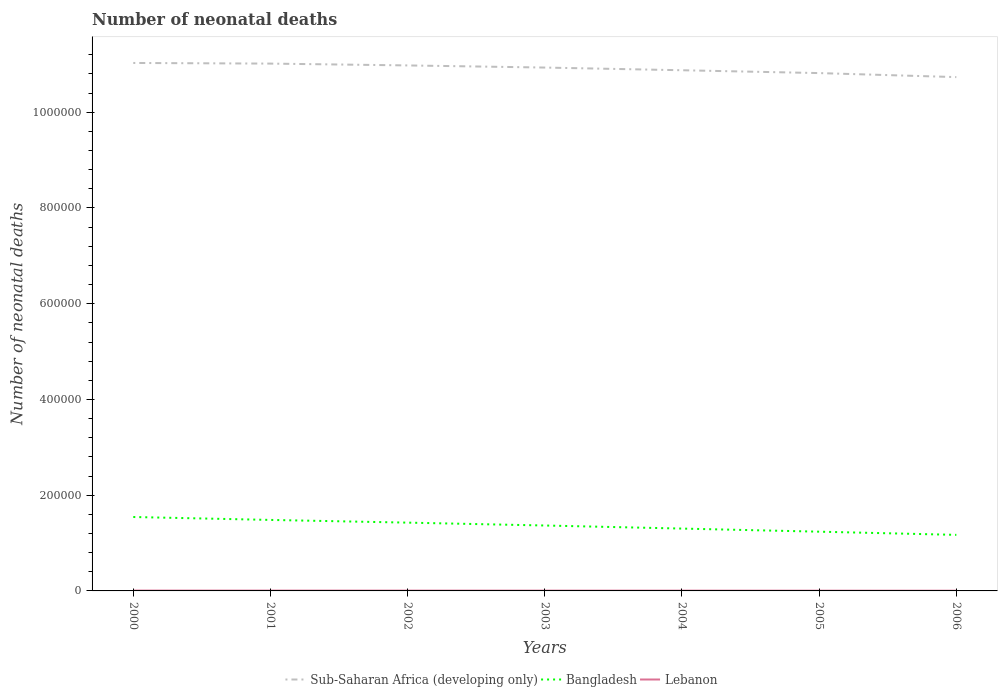Does the line corresponding to Bangladesh intersect with the line corresponding to Lebanon?
Your answer should be compact. No. Is the number of lines equal to the number of legend labels?
Your answer should be very brief. Yes. Across all years, what is the maximum number of neonatal deaths in in Bangladesh?
Keep it short and to the point. 1.17e+05. What is the total number of neonatal deaths in in Lebanon in the graph?
Make the answer very short. 65. What is the difference between the highest and the second highest number of neonatal deaths in in Bangladesh?
Keep it short and to the point. 3.73e+04. How many years are there in the graph?
Your response must be concise. 7. What is the difference between two consecutive major ticks on the Y-axis?
Keep it short and to the point. 2.00e+05. Are the values on the major ticks of Y-axis written in scientific E-notation?
Provide a succinct answer. No. Does the graph contain any zero values?
Your response must be concise. No. Does the graph contain grids?
Provide a succinct answer. No. What is the title of the graph?
Provide a short and direct response. Number of neonatal deaths. Does "Algeria" appear as one of the legend labels in the graph?
Provide a succinct answer. No. What is the label or title of the X-axis?
Give a very brief answer. Years. What is the label or title of the Y-axis?
Your answer should be compact. Number of neonatal deaths. What is the Number of neonatal deaths of Sub-Saharan Africa (developing only) in 2000?
Keep it short and to the point. 1.10e+06. What is the Number of neonatal deaths of Bangladesh in 2000?
Give a very brief answer. 1.54e+05. What is the Number of neonatal deaths in Lebanon in 2000?
Your answer should be very brief. 720. What is the Number of neonatal deaths in Sub-Saharan Africa (developing only) in 2001?
Keep it short and to the point. 1.10e+06. What is the Number of neonatal deaths in Bangladesh in 2001?
Your answer should be compact. 1.48e+05. What is the Number of neonatal deaths in Lebanon in 2001?
Provide a short and direct response. 678. What is the Number of neonatal deaths of Sub-Saharan Africa (developing only) in 2002?
Provide a succinct answer. 1.10e+06. What is the Number of neonatal deaths in Bangladesh in 2002?
Your response must be concise. 1.43e+05. What is the Number of neonatal deaths in Lebanon in 2002?
Give a very brief answer. 641. What is the Number of neonatal deaths of Sub-Saharan Africa (developing only) in 2003?
Ensure brevity in your answer.  1.09e+06. What is the Number of neonatal deaths of Bangladesh in 2003?
Your response must be concise. 1.37e+05. What is the Number of neonatal deaths of Lebanon in 2003?
Your answer should be compact. 613. What is the Number of neonatal deaths in Sub-Saharan Africa (developing only) in 2004?
Provide a succinct answer. 1.09e+06. What is the Number of neonatal deaths in Bangladesh in 2004?
Provide a succinct answer. 1.30e+05. What is the Number of neonatal deaths in Lebanon in 2004?
Keep it short and to the point. 572. What is the Number of neonatal deaths in Sub-Saharan Africa (developing only) in 2005?
Provide a short and direct response. 1.08e+06. What is the Number of neonatal deaths in Bangladesh in 2005?
Keep it short and to the point. 1.24e+05. What is the Number of neonatal deaths of Lebanon in 2005?
Your answer should be compact. 513. What is the Number of neonatal deaths of Sub-Saharan Africa (developing only) in 2006?
Your answer should be very brief. 1.07e+06. What is the Number of neonatal deaths of Bangladesh in 2006?
Your answer should be very brief. 1.17e+05. What is the Number of neonatal deaths of Lebanon in 2006?
Your answer should be very brief. 443. Across all years, what is the maximum Number of neonatal deaths of Sub-Saharan Africa (developing only)?
Your answer should be very brief. 1.10e+06. Across all years, what is the maximum Number of neonatal deaths of Bangladesh?
Ensure brevity in your answer.  1.54e+05. Across all years, what is the maximum Number of neonatal deaths in Lebanon?
Give a very brief answer. 720. Across all years, what is the minimum Number of neonatal deaths in Sub-Saharan Africa (developing only)?
Ensure brevity in your answer.  1.07e+06. Across all years, what is the minimum Number of neonatal deaths in Bangladesh?
Your response must be concise. 1.17e+05. Across all years, what is the minimum Number of neonatal deaths of Lebanon?
Your answer should be compact. 443. What is the total Number of neonatal deaths in Sub-Saharan Africa (developing only) in the graph?
Offer a terse response. 7.64e+06. What is the total Number of neonatal deaths of Bangladesh in the graph?
Give a very brief answer. 9.53e+05. What is the total Number of neonatal deaths of Lebanon in the graph?
Your response must be concise. 4180. What is the difference between the Number of neonatal deaths of Sub-Saharan Africa (developing only) in 2000 and that in 2001?
Make the answer very short. 1326. What is the difference between the Number of neonatal deaths in Bangladesh in 2000 and that in 2001?
Make the answer very short. 6113. What is the difference between the Number of neonatal deaths of Sub-Saharan Africa (developing only) in 2000 and that in 2002?
Offer a terse response. 5137. What is the difference between the Number of neonatal deaths of Bangladesh in 2000 and that in 2002?
Give a very brief answer. 1.18e+04. What is the difference between the Number of neonatal deaths of Lebanon in 2000 and that in 2002?
Your answer should be very brief. 79. What is the difference between the Number of neonatal deaths in Sub-Saharan Africa (developing only) in 2000 and that in 2003?
Provide a short and direct response. 9601. What is the difference between the Number of neonatal deaths in Bangladesh in 2000 and that in 2003?
Provide a short and direct response. 1.78e+04. What is the difference between the Number of neonatal deaths in Lebanon in 2000 and that in 2003?
Offer a very short reply. 107. What is the difference between the Number of neonatal deaths in Sub-Saharan Africa (developing only) in 2000 and that in 2004?
Make the answer very short. 1.52e+04. What is the difference between the Number of neonatal deaths in Bangladesh in 2000 and that in 2004?
Offer a very short reply. 2.42e+04. What is the difference between the Number of neonatal deaths in Lebanon in 2000 and that in 2004?
Provide a short and direct response. 148. What is the difference between the Number of neonatal deaths of Sub-Saharan Africa (developing only) in 2000 and that in 2005?
Your answer should be compact. 2.11e+04. What is the difference between the Number of neonatal deaths in Bangladesh in 2000 and that in 2005?
Provide a short and direct response. 3.07e+04. What is the difference between the Number of neonatal deaths in Lebanon in 2000 and that in 2005?
Offer a terse response. 207. What is the difference between the Number of neonatal deaths of Sub-Saharan Africa (developing only) in 2000 and that in 2006?
Your answer should be very brief. 2.95e+04. What is the difference between the Number of neonatal deaths in Bangladesh in 2000 and that in 2006?
Your response must be concise. 3.73e+04. What is the difference between the Number of neonatal deaths of Lebanon in 2000 and that in 2006?
Offer a very short reply. 277. What is the difference between the Number of neonatal deaths of Sub-Saharan Africa (developing only) in 2001 and that in 2002?
Your answer should be very brief. 3811. What is the difference between the Number of neonatal deaths in Bangladesh in 2001 and that in 2002?
Give a very brief answer. 5643. What is the difference between the Number of neonatal deaths of Sub-Saharan Africa (developing only) in 2001 and that in 2003?
Provide a short and direct response. 8275. What is the difference between the Number of neonatal deaths in Bangladesh in 2001 and that in 2003?
Keep it short and to the point. 1.16e+04. What is the difference between the Number of neonatal deaths of Lebanon in 2001 and that in 2003?
Offer a very short reply. 65. What is the difference between the Number of neonatal deaths of Sub-Saharan Africa (developing only) in 2001 and that in 2004?
Make the answer very short. 1.39e+04. What is the difference between the Number of neonatal deaths of Bangladesh in 2001 and that in 2004?
Keep it short and to the point. 1.81e+04. What is the difference between the Number of neonatal deaths of Lebanon in 2001 and that in 2004?
Your answer should be compact. 106. What is the difference between the Number of neonatal deaths in Sub-Saharan Africa (developing only) in 2001 and that in 2005?
Your response must be concise. 1.98e+04. What is the difference between the Number of neonatal deaths of Bangladesh in 2001 and that in 2005?
Offer a terse response. 2.46e+04. What is the difference between the Number of neonatal deaths of Lebanon in 2001 and that in 2005?
Provide a succinct answer. 165. What is the difference between the Number of neonatal deaths of Sub-Saharan Africa (developing only) in 2001 and that in 2006?
Provide a succinct answer. 2.82e+04. What is the difference between the Number of neonatal deaths of Bangladesh in 2001 and that in 2006?
Give a very brief answer. 3.12e+04. What is the difference between the Number of neonatal deaths of Lebanon in 2001 and that in 2006?
Make the answer very short. 235. What is the difference between the Number of neonatal deaths in Sub-Saharan Africa (developing only) in 2002 and that in 2003?
Your answer should be very brief. 4464. What is the difference between the Number of neonatal deaths of Bangladesh in 2002 and that in 2003?
Provide a succinct answer. 6004. What is the difference between the Number of neonatal deaths in Sub-Saharan Africa (developing only) in 2002 and that in 2004?
Ensure brevity in your answer.  1.01e+04. What is the difference between the Number of neonatal deaths in Bangladesh in 2002 and that in 2004?
Provide a succinct answer. 1.24e+04. What is the difference between the Number of neonatal deaths of Lebanon in 2002 and that in 2004?
Ensure brevity in your answer.  69. What is the difference between the Number of neonatal deaths of Sub-Saharan Africa (developing only) in 2002 and that in 2005?
Offer a very short reply. 1.60e+04. What is the difference between the Number of neonatal deaths in Bangladesh in 2002 and that in 2005?
Offer a terse response. 1.89e+04. What is the difference between the Number of neonatal deaths in Lebanon in 2002 and that in 2005?
Your response must be concise. 128. What is the difference between the Number of neonatal deaths in Sub-Saharan Africa (developing only) in 2002 and that in 2006?
Make the answer very short. 2.44e+04. What is the difference between the Number of neonatal deaths of Bangladesh in 2002 and that in 2006?
Give a very brief answer. 2.56e+04. What is the difference between the Number of neonatal deaths of Lebanon in 2002 and that in 2006?
Your answer should be very brief. 198. What is the difference between the Number of neonatal deaths in Sub-Saharan Africa (developing only) in 2003 and that in 2004?
Keep it short and to the point. 5609. What is the difference between the Number of neonatal deaths of Bangladesh in 2003 and that in 2004?
Your response must be concise. 6423. What is the difference between the Number of neonatal deaths in Sub-Saharan Africa (developing only) in 2003 and that in 2005?
Give a very brief answer. 1.15e+04. What is the difference between the Number of neonatal deaths of Bangladesh in 2003 and that in 2005?
Ensure brevity in your answer.  1.29e+04. What is the difference between the Number of neonatal deaths in Sub-Saharan Africa (developing only) in 2003 and that in 2006?
Provide a short and direct response. 1.99e+04. What is the difference between the Number of neonatal deaths in Bangladesh in 2003 and that in 2006?
Ensure brevity in your answer.  1.96e+04. What is the difference between the Number of neonatal deaths in Lebanon in 2003 and that in 2006?
Offer a terse response. 170. What is the difference between the Number of neonatal deaths of Sub-Saharan Africa (developing only) in 2004 and that in 2005?
Your answer should be compact. 5939. What is the difference between the Number of neonatal deaths of Bangladesh in 2004 and that in 2005?
Give a very brief answer. 6481. What is the difference between the Number of neonatal deaths of Sub-Saharan Africa (developing only) in 2004 and that in 2006?
Your answer should be very brief. 1.43e+04. What is the difference between the Number of neonatal deaths of Bangladesh in 2004 and that in 2006?
Give a very brief answer. 1.31e+04. What is the difference between the Number of neonatal deaths in Lebanon in 2004 and that in 2006?
Give a very brief answer. 129. What is the difference between the Number of neonatal deaths in Sub-Saharan Africa (developing only) in 2005 and that in 2006?
Your answer should be very brief. 8397. What is the difference between the Number of neonatal deaths of Bangladesh in 2005 and that in 2006?
Provide a short and direct response. 6658. What is the difference between the Number of neonatal deaths of Lebanon in 2005 and that in 2006?
Make the answer very short. 70. What is the difference between the Number of neonatal deaths in Sub-Saharan Africa (developing only) in 2000 and the Number of neonatal deaths in Bangladesh in 2001?
Keep it short and to the point. 9.55e+05. What is the difference between the Number of neonatal deaths in Sub-Saharan Africa (developing only) in 2000 and the Number of neonatal deaths in Lebanon in 2001?
Provide a short and direct response. 1.10e+06. What is the difference between the Number of neonatal deaths of Bangladesh in 2000 and the Number of neonatal deaths of Lebanon in 2001?
Provide a short and direct response. 1.54e+05. What is the difference between the Number of neonatal deaths in Sub-Saharan Africa (developing only) in 2000 and the Number of neonatal deaths in Bangladesh in 2002?
Your response must be concise. 9.60e+05. What is the difference between the Number of neonatal deaths of Sub-Saharan Africa (developing only) in 2000 and the Number of neonatal deaths of Lebanon in 2002?
Make the answer very short. 1.10e+06. What is the difference between the Number of neonatal deaths of Bangladesh in 2000 and the Number of neonatal deaths of Lebanon in 2002?
Your answer should be compact. 1.54e+05. What is the difference between the Number of neonatal deaths in Sub-Saharan Africa (developing only) in 2000 and the Number of neonatal deaths in Bangladesh in 2003?
Offer a terse response. 9.66e+05. What is the difference between the Number of neonatal deaths of Sub-Saharan Africa (developing only) in 2000 and the Number of neonatal deaths of Lebanon in 2003?
Provide a short and direct response. 1.10e+06. What is the difference between the Number of neonatal deaths of Bangladesh in 2000 and the Number of neonatal deaths of Lebanon in 2003?
Provide a short and direct response. 1.54e+05. What is the difference between the Number of neonatal deaths in Sub-Saharan Africa (developing only) in 2000 and the Number of neonatal deaths in Bangladesh in 2004?
Provide a short and direct response. 9.73e+05. What is the difference between the Number of neonatal deaths in Sub-Saharan Africa (developing only) in 2000 and the Number of neonatal deaths in Lebanon in 2004?
Provide a short and direct response. 1.10e+06. What is the difference between the Number of neonatal deaths in Bangladesh in 2000 and the Number of neonatal deaths in Lebanon in 2004?
Give a very brief answer. 1.54e+05. What is the difference between the Number of neonatal deaths of Sub-Saharan Africa (developing only) in 2000 and the Number of neonatal deaths of Bangladesh in 2005?
Your answer should be compact. 9.79e+05. What is the difference between the Number of neonatal deaths of Sub-Saharan Africa (developing only) in 2000 and the Number of neonatal deaths of Lebanon in 2005?
Your response must be concise. 1.10e+06. What is the difference between the Number of neonatal deaths in Bangladesh in 2000 and the Number of neonatal deaths in Lebanon in 2005?
Ensure brevity in your answer.  1.54e+05. What is the difference between the Number of neonatal deaths in Sub-Saharan Africa (developing only) in 2000 and the Number of neonatal deaths in Bangladesh in 2006?
Ensure brevity in your answer.  9.86e+05. What is the difference between the Number of neonatal deaths in Sub-Saharan Africa (developing only) in 2000 and the Number of neonatal deaths in Lebanon in 2006?
Give a very brief answer. 1.10e+06. What is the difference between the Number of neonatal deaths of Bangladesh in 2000 and the Number of neonatal deaths of Lebanon in 2006?
Keep it short and to the point. 1.54e+05. What is the difference between the Number of neonatal deaths of Sub-Saharan Africa (developing only) in 2001 and the Number of neonatal deaths of Bangladesh in 2002?
Ensure brevity in your answer.  9.59e+05. What is the difference between the Number of neonatal deaths in Sub-Saharan Africa (developing only) in 2001 and the Number of neonatal deaths in Lebanon in 2002?
Offer a terse response. 1.10e+06. What is the difference between the Number of neonatal deaths in Bangladesh in 2001 and the Number of neonatal deaths in Lebanon in 2002?
Your answer should be very brief. 1.48e+05. What is the difference between the Number of neonatal deaths of Sub-Saharan Africa (developing only) in 2001 and the Number of neonatal deaths of Bangladesh in 2003?
Your response must be concise. 9.65e+05. What is the difference between the Number of neonatal deaths in Sub-Saharan Africa (developing only) in 2001 and the Number of neonatal deaths in Lebanon in 2003?
Your response must be concise. 1.10e+06. What is the difference between the Number of neonatal deaths in Bangladesh in 2001 and the Number of neonatal deaths in Lebanon in 2003?
Provide a short and direct response. 1.48e+05. What is the difference between the Number of neonatal deaths of Sub-Saharan Africa (developing only) in 2001 and the Number of neonatal deaths of Bangladesh in 2004?
Your answer should be compact. 9.71e+05. What is the difference between the Number of neonatal deaths of Sub-Saharan Africa (developing only) in 2001 and the Number of neonatal deaths of Lebanon in 2004?
Provide a short and direct response. 1.10e+06. What is the difference between the Number of neonatal deaths in Bangladesh in 2001 and the Number of neonatal deaths in Lebanon in 2004?
Keep it short and to the point. 1.48e+05. What is the difference between the Number of neonatal deaths of Sub-Saharan Africa (developing only) in 2001 and the Number of neonatal deaths of Bangladesh in 2005?
Offer a very short reply. 9.78e+05. What is the difference between the Number of neonatal deaths in Sub-Saharan Africa (developing only) in 2001 and the Number of neonatal deaths in Lebanon in 2005?
Your response must be concise. 1.10e+06. What is the difference between the Number of neonatal deaths in Bangladesh in 2001 and the Number of neonatal deaths in Lebanon in 2005?
Offer a very short reply. 1.48e+05. What is the difference between the Number of neonatal deaths of Sub-Saharan Africa (developing only) in 2001 and the Number of neonatal deaths of Bangladesh in 2006?
Ensure brevity in your answer.  9.85e+05. What is the difference between the Number of neonatal deaths of Sub-Saharan Africa (developing only) in 2001 and the Number of neonatal deaths of Lebanon in 2006?
Give a very brief answer. 1.10e+06. What is the difference between the Number of neonatal deaths in Bangladesh in 2001 and the Number of neonatal deaths in Lebanon in 2006?
Your response must be concise. 1.48e+05. What is the difference between the Number of neonatal deaths of Sub-Saharan Africa (developing only) in 2002 and the Number of neonatal deaths of Bangladesh in 2003?
Offer a terse response. 9.61e+05. What is the difference between the Number of neonatal deaths in Sub-Saharan Africa (developing only) in 2002 and the Number of neonatal deaths in Lebanon in 2003?
Make the answer very short. 1.10e+06. What is the difference between the Number of neonatal deaths in Bangladesh in 2002 and the Number of neonatal deaths in Lebanon in 2003?
Your answer should be very brief. 1.42e+05. What is the difference between the Number of neonatal deaths of Sub-Saharan Africa (developing only) in 2002 and the Number of neonatal deaths of Bangladesh in 2004?
Your answer should be very brief. 9.68e+05. What is the difference between the Number of neonatal deaths in Sub-Saharan Africa (developing only) in 2002 and the Number of neonatal deaths in Lebanon in 2004?
Offer a very short reply. 1.10e+06. What is the difference between the Number of neonatal deaths in Bangladesh in 2002 and the Number of neonatal deaths in Lebanon in 2004?
Your answer should be very brief. 1.42e+05. What is the difference between the Number of neonatal deaths in Sub-Saharan Africa (developing only) in 2002 and the Number of neonatal deaths in Bangladesh in 2005?
Your answer should be compact. 9.74e+05. What is the difference between the Number of neonatal deaths of Sub-Saharan Africa (developing only) in 2002 and the Number of neonatal deaths of Lebanon in 2005?
Give a very brief answer. 1.10e+06. What is the difference between the Number of neonatal deaths of Bangladesh in 2002 and the Number of neonatal deaths of Lebanon in 2005?
Offer a very short reply. 1.42e+05. What is the difference between the Number of neonatal deaths of Sub-Saharan Africa (developing only) in 2002 and the Number of neonatal deaths of Bangladesh in 2006?
Keep it short and to the point. 9.81e+05. What is the difference between the Number of neonatal deaths in Sub-Saharan Africa (developing only) in 2002 and the Number of neonatal deaths in Lebanon in 2006?
Your answer should be very brief. 1.10e+06. What is the difference between the Number of neonatal deaths in Bangladesh in 2002 and the Number of neonatal deaths in Lebanon in 2006?
Your response must be concise. 1.42e+05. What is the difference between the Number of neonatal deaths in Sub-Saharan Africa (developing only) in 2003 and the Number of neonatal deaths in Bangladesh in 2004?
Ensure brevity in your answer.  9.63e+05. What is the difference between the Number of neonatal deaths in Sub-Saharan Africa (developing only) in 2003 and the Number of neonatal deaths in Lebanon in 2004?
Provide a succinct answer. 1.09e+06. What is the difference between the Number of neonatal deaths in Bangladesh in 2003 and the Number of neonatal deaths in Lebanon in 2004?
Give a very brief answer. 1.36e+05. What is the difference between the Number of neonatal deaths in Sub-Saharan Africa (developing only) in 2003 and the Number of neonatal deaths in Bangladesh in 2005?
Give a very brief answer. 9.70e+05. What is the difference between the Number of neonatal deaths in Sub-Saharan Africa (developing only) in 2003 and the Number of neonatal deaths in Lebanon in 2005?
Provide a succinct answer. 1.09e+06. What is the difference between the Number of neonatal deaths of Bangladesh in 2003 and the Number of neonatal deaths of Lebanon in 2005?
Keep it short and to the point. 1.36e+05. What is the difference between the Number of neonatal deaths of Sub-Saharan Africa (developing only) in 2003 and the Number of neonatal deaths of Bangladesh in 2006?
Provide a succinct answer. 9.76e+05. What is the difference between the Number of neonatal deaths in Sub-Saharan Africa (developing only) in 2003 and the Number of neonatal deaths in Lebanon in 2006?
Keep it short and to the point. 1.09e+06. What is the difference between the Number of neonatal deaths in Bangladesh in 2003 and the Number of neonatal deaths in Lebanon in 2006?
Give a very brief answer. 1.36e+05. What is the difference between the Number of neonatal deaths in Sub-Saharan Africa (developing only) in 2004 and the Number of neonatal deaths in Bangladesh in 2005?
Provide a short and direct response. 9.64e+05. What is the difference between the Number of neonatal deaths in Sub-Saharan Africa (developing only) in 2004 and the Number of neonatal deaths in Lebanon in 2005?
Offer a very short reply. 1.09e+06. What is the difference between the Number of neonatal deaths in Bangladesh in 2004 and the Number of neonatal deaths in Lebanon in 2005?
Provide a short and direct response. 1.30e+05. What is the difference between the Number of neonatal deaths in Sub-Saharan Africa (developing only) in 2004 and the Number of neonatal deaths in Bangladesh in 2006?
Provide a succinct answer. 9.71e+05. What is the difference between the Number of neonatal deaths in Sub-Saharan Africa (developing only) in 2004 and the Number of neonatal deaths in Lebanon in 2006?
Keep it short and to the point. 1.09e+06. What is the difference between the Number of neonatal deaths in Bangladesh in 2004 and the Number of neonatal deaths in Lebanon in 2006?
Ensure brevity in your answer.  1.30e+05. What is the difference between the Number of neonatal deaths in Sub-Saharan Africa (developing only) in 2005 and the Number of neonatal deaths in Bangladesh in 2006?
Your answer should be very brief. 9.65e+05. What is the difference between the Number of neonatal deaths of Sub-Saharan Africa (developing only) in 2005 and the Number of neonatal deaths of Lebanon in 2006?
Offer a very short reply. 1.08e+06. What is the difference between the Number of neonatal deaths of Bangladesh in 2005 and the Number of neonatal deaths of Lebanon in 2006?
Provide a short and direct response. 1.23e+05. What is the average Number of neonatal deaths in Sub-Saharan Africa (developing only) per year?
Make the answer very short. 1.09e+06. What is the average Number of neonatal deaths in Bangladesh per year?
Ensure brevity in your answer.  1.36e+05. What is the average Number of neonatal deaths in Lebanon per year?
Your answer should be very brief. 597.14. In the year 2000, what is the difference between the Number of neonatal deaths in Sub-Saharan Africa (developing only) and Number of neonatal deaths in Bangladesh?
Ensure brevity in your answer.  9.49e+05. In the year 2000, what is the difference between the Number of neonatal deaths in Sub-Saharan Africa (developing only) and Number of neonatal deaths in Lebanon?
Provide a succinct answer. 1.10e+06. In the year 2000, what is the difference between the Number of neonatal deaths in Bangladesh and Number of neonatal deaths in Lebanon?
Your answer should be very brief. 1.54e+05. In the year 2001, what is the difference between the Number of neonatal deaths in Sub-Saharan Africa (developing only) and Number of neonatal deaths in Bangladesh?
Your response must be concise. 9.53e+05. In the year 2001, what is the difference between the Number of neonatal deaths of Sub-Saharan Africa (developing only) and Number of neonatal deaths of Lebanon?
Keep it short and to the point. 1.10e+06. In the year 2001, what is the difference between the Number of neonatal deaths in Bangladesh and Number of neonatal deaths in Lebanon?
Keep it short and to the point. 1.48e+05. In the year 2002, what is the difference between the Number of neonatal deaths of Sub-Saharan Africa (developing only) and Number of neonatal deaths of Bangladesh?
Your answer should be very brief. 9.55e+05. In the year 2002, what is the difference between the Number of neonatal deaths in Sub-Saharan Africa (developing only) and Number of neonatal deaths in Lebanon?
Your response must be concise. 1.10e+06. In the year 2002, what is the difference between the Number of neonatal deaths of Bangladesh and Number of neonatal deaths of Lebanon?
Your answer should be compact. 1.42e+05. In the year 2003, what is the difference between the Number of neonatal deaths of Sub-Saharan Africa (developing only) and Number of neonatal deaths of Bangladesh?
Your answer should be compact. 9.57e+05. In the year 2003, what is the difference between the Number of neonatal deaths in Sub-Saharan Africa (developing only) and Number of neonatal deaths in Lebanon?
Give a very brief answer. 1.09e+06. In the year 2003, what is the difference between the Number of neonatal deaths in Bangladesh and Number of neonatal deaths in Lebanon?
Keep it short and to the point. 1.36e+05. In the year 2004, what is the difference between the Number of neonatal deaths in Sub-Saharan Africa (developing only) and Number of neonatal deaths in Bangladesh?
Offer a terse response. 9.58e+05. In the year 2004, what is the difference between the Number of neonatal deaths of Sub-Saharan Africa (developing only) and Number of neonatal deaths of Lebanon?
Provide a short and direct response. 1.09e+06. In the year 2004, what is the difference between the Number of neonatal deaths in Bangladesh and Number of neonatal deaths in Lebanon?
Offer a very short reply. 1.30e+05. In the year 2005, what is the difference between the Number of neonatal deaths of Sub-Saharan Africa (developing only) and Number of neonatal deaths of Bangladesh?
Give a very brief answer. 9.58e+05. In the year 2005, what is the difference between the Number of neonatal deaths of Sub-Saharan Africa (developing only) and Number of neonatal deaths of Lebanon?
Your answer should be compact. 1.08e+06. In the year 2005, what is the difference between the Number of neonatal deaths in Bangladesh and Number of neonatal deaths in Lebanon?
Provide a short and direct response. 1.23e+05. In the year 2006, what is the difference between the Number of neonatal deaths of Sub-Saharan Africa (developing only) and Number of neonatal deaths of Bangladesh?
Your answer should be compact. 9.56e+05. In the year 2006, what is the difference between the Number of neonatal deaths of Sub-Saharan Africa (developing only) and Number of neonatal deaths of Lebanon?
Your response must be concise. 1.07e+06. In the year 2006, what is the difference between the Number of neonatal deaths of Bangladesh and Number of neonatal deaths of Lebanon?
Ensure brevity in your answer.  1.17e+05. What is the ratio of the Number of neonatal deaths in Bangladesh in 2000 to that in 2001?
Keep it short and to the point. 1.04. What is the ratio of the Number of neonatal deaths of Lebanon in 2000 to that in 2001?
Provide a succinct answer. 1.06. What is the ratio of the Number of neonatal deaths in Sub-Saharan Africa (developing only) in 2000 to that in 2002?
Your answer should be very brief. 1. What is the ratio of the Number of neonatal deaths in Bangladesh in 2000 to that in 2002?
Offer a very short reply. 1.08. What is the ratio of the Number of neonatal deaths of Lebanon in 2000 to that in 2002?
Ensure brevity in your answer.  1.12. What is the ratio of the Number of neonatal deaths in Sub-Saharan Africa (developing only) in 2000 to that in 2003?
Ensure brevity in your answer.  1.01. What is the ratio of the Number of neonatal deaths in Bangladesh in 2000 to that in 2003?
Offer a terse response. 1.13. What is the ratio of the Number of neonatal deaths in Lebanon in 2000 to that in 2003?
Make the answer very short. 1.17. What is the ratio of the Number of neonatal deaths in Sub-Saharan Africa (developing only) in 2000 to that in 2004?
Make the answer very short. 1.01. What is the ratio of the Number of neonatal deaths in Bangladesh in 2000 to that in 2004?
Give a very brief answer. 1.19. What is the ratio of the Number of neonatal deaths of Lebanon in 2000 to that in 2004?
Make the answer very short. 1.26. What is the ratio of the Number of neonatal deaths in Sub-Saharan Africa (developing only) in 2000 to that in 2005?
Ensure brevity in your answer.  1.02. What is the ratio of the Number of neonatal deaths of Bangladesh in 2000 to that in 2005?
Make the answer very short. 1.25. What is the ratio of the Number of neonatal deaths of Lebanon in 2000 to that in 2005?
Ensure brevity in your answer.  1.4. What is the ratio of the Number of neonatal deaths in Sub-Saharan Africa (developing only) in 2000 to that in 2006?
Provide a short and direct response. 1.03. What is the ratio of the Number of neonatal deaths in Bangladesh in 2000 to that in 2006?
Offer a terse response. 1.32. What is the ratio of the Number of neonatal deaths in Lebanon in 2000 to that in 2006?
Make the answer very short. 1.63. What is the ratio of the Number of neonatal deaths of Sub-Saharan Africa (developing only) in 2001 to that in 2002?
Offer a terse response. 1. What is the ratio of the Number of neonatal deaths of Bangladesh in 2001 to that in 2002?
Provide a short and direct response. 1.04. What is the ratio of the Number of neonatal deaths in Lebanon in 2001 to that in 2002?
Offer a very short reply. 1.06. What is the ratio of the Number of neonatal deaths in Sub-Saharan Africa (developing only) in 2001 to that in 2003?
Offer a terse response. 1.01. What is the ratio of the Number of neonatal deaths of Bangladesh in 2001 to that in 2003?
Give a very brief answer. 1.09. What is the ratio of the Number of neonatal deaths of Lebanon in 2001 to that in 2003?
Offer a terse response. 1.11. What is the ratio of the Number of neonatal deaths in Sub-Saharan Africa (developing only) in 2001 to that in 2004?
Give a very brief answer. 1.01. What is the ratio of the Number of neonatal deaths of Bangladesh in 2001 to that in 2004?
Offer a terse response. 1.14. What is the ratio of the Number of neonatal deaths of Lebanon in 2001 to that in 2004?
Your answer should be compact. 1.19. What is the ratio of the Number of neonatal deaths in Sub-Saharan Africa (developing only) in 2001 to that in 2005?
Keep it short and to the point. 1.02. What is the ratio of the Number of neonatal deaths of Bangladesh in 2001 to that in 2005?
Keep it short and to the point. 1.2. What is the ratio of the Number of neonatal deaths in Lebanon in 2001 to that in 2005?
Make the answer very short. 1.32. What is the ratio of the Number of neonatal deaths in Sub-Saharan Africa (developing only) in 2001 to that in 2006?
Offer a terse response. 1.03. What is the ratio of the Number of neonatal deaths of Bangladesh in 2001 to that in 2006?
Keep it short and to the point. 1.27. What is the ratio of the Number of neonatal deaths in Lebanon in 2001 to that in 2006?
Ensure brevity in your answer.  1.53. What is the ratio of the Number of neonatal deaths of Bangladesh in 2002 to that in 2003?
Your answer should be very brief. 1.04. What is the ratio of the Number of neonatal deaths of Lebanon in 2002 to that in 2003?
Your response must be concise. 1.05. What is the ratio of the Number of neonatal deaths in Sub-Saharan Africa (developing only) in 2002 to that in 2004?
Keep it short and to the point. 1.01. What is the ratio of the Number of neonatal deaths in Bangladesh in 2002 to that in 2004?
Give a very brief answer. 1.1. What is the ratio of the Number of neonatal deaths in Lebanon in 2002 to that in 2004?
Ensure brevity in your answer.  1.12. What is the ratio of the Number of neonatal deaths in Sub-Saharan Africa (developing only) in 2002 to that in 2005?
Your answer should be compact. 1.01. What is the ratio of the Number of neonatal deaths of Bangladesh in 2002 to that in 2005?
Give a very brief answer. 1.15. What is the ratio of the Number of neonatal deaths in Lebanon in 2002 to that in 2005?
Your response must be concise. 1.25. What is the ratio of the Number of neonatal deaths in Sub-Saharan Africa (developing only) in 2002 to that in 2006?
Your response must be concise. 1.02. What is the ratio of the Number of neonatal deaths in Bangladesh in 2002 to that in 2006?
Keep it short and to the point. 1.22. What is the ratio of the Number of neonatal deaths in Lebanon in 2002 to that in 2006?
Make the answer very short. 1.45. What is the ratio of the Number of neonatal deaths of Sub-Saharan Africa (developing only) in 2003 to that in 2004?
Provide a short and direct response. 1.01. What is the ratio of the Number of neonatal deaths of Bangladesh in 2003 to that in 2004?
Provide a succinct answer. 1.05. What is the ratio of the Number of neonatal deaths in Lebanon in 2003 to that in 2004?
Your answer should be very brief. 1.07. What is the ratio of the Number of neonatal deaths in Sub-Saharan Africa (developing only) in 2003 to that in 2005?
Your answer should be compact. 1.01. What is the ratio of the Number of neonatal deaths in Bangladesh in 2003 to that in 2005?
Make the answer very short. 1.1. What is the ratio of the Number of neonatal deaths of Lebanon in 2003 to that in 2005?
Your response must be concise. 1.19. What is the ratio of the Number of neonatal deaths of Sub-Saharan Africa (developing only) in 2003 to that in 2006?
Provide a short and direct response. 1.02. What is the ratio of the Number of neonatal deaths of Bangladesh in 2003 to that in 2006?
Offer a terse response. 1.17. What is the ratio of the Number of neonatal deaths of Lebanon in 2003 to that in 2006?
Provide a short and direct response. 1.38. What is the ratio of the Number of neonatal deaths in Bangladesh in 2004 to that in 2005?
Offer a very short reply. 1.05. What is the ratio of the Number of neonatal deaths in Lebanon in 2004 to that in 2005?
Give a very brief answer. 1.11. What is the ratio of the Number of neonatal deaths of Sub-Saharan Africa (developing only) in 2004 to that in 2006?
Provide a short and direct response. 1.01. What is the ratio of the Number of neonatal deaths in Bangladesh in 2004 to that in 2006?
Provide a short and direct response. 1.11. What is the ratio of the Number of neonatal deaths of Lebanon in 2004 to that in 2006?
Offer a very short reply. 1.29. What is the ratio of the Number of neonatal deaths of Bangladesh in 2005 to that in 2006?
Offer a terse response. 1.06. What is the ratio of the Number of neonatal deaths of Lebanon in 2005 to that in 2006?
Your answer should be very brief. 1.16. What is the difference between the highest and the second highest Number of neonatal deaths of Sub-Saharan Africa (developing only)?
Give a very brief answer. 1326. What is the difference between the highest and the second highest Number of neonatal deaths in Bangladesh?
Provide a short and direct response. 6113. What is the difference between the highest and the lowest Number of neonatal deaths of Sub-Saharan Africa (developing only)?
Your answer should be very brief. 2.95e+04. What is the difference between the highest and the lowest Number of neonatal deaths in Bangladesh?
Your answer should be very brief. 3.73e+04. What is the difference between the highest and the lowest Number of neonatal deaths in Lebanon?
Your response must be concise. 277. 